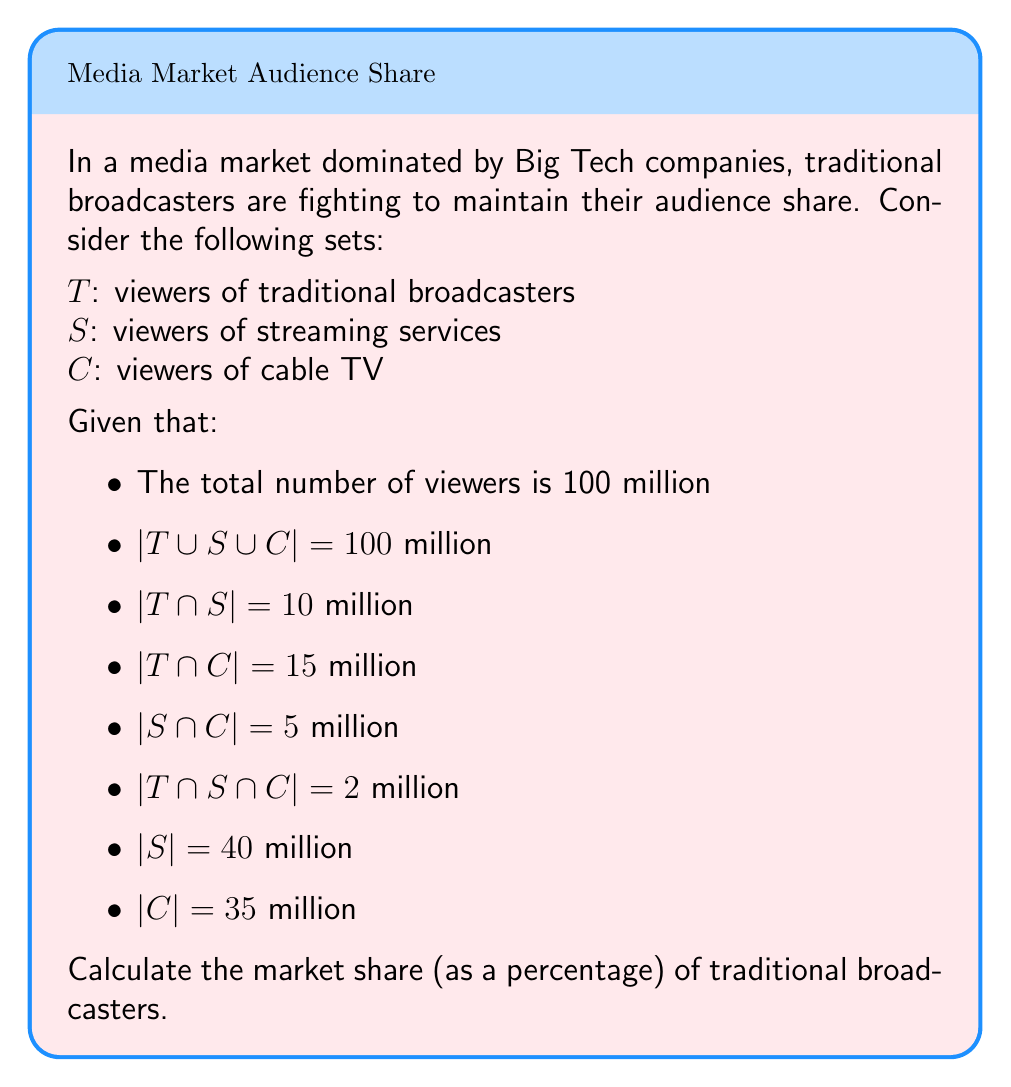Show me your answer to this math problem. To solve this problem, we'll use the Inclusion-Exclusion Principle from set theory.

1) First, let's recall the formula for three sets:

   $$|T \cup S \cup C| = |T| + |S| + |C| - |T \cap S| - |T \cap C| - |S \cap C| + |T \cap S \cap C|$$

2) We know the left side of the equation and most of the right side:

   $$100 = |T| + 40 + 35 - 10 - 15 - 5 + 2$$

3) Let's solve for $|T|$:

   $$|T| = 100 - 40 - 35 + 10 + 15 + 5 - 2 = 53$$ million

4) So, there are 53 million viewers of traditional broadcasters.

5) To calculate the market share as a percentage, we divide this by the total number of viewers and multiply by 100:

   $$\text{Market Share} = \frac{|T|}{\text{Total Viewers}} \times 100\% = \frac{53}{100} \times 100\% = 53\%$$

Therefore, the market share of traditional broadcasters is 53%.
Answer: 53% 